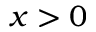Convert formula to latex. <formula><loc_0><loc_0><loc_500><loc_500>x > 0</formula> 